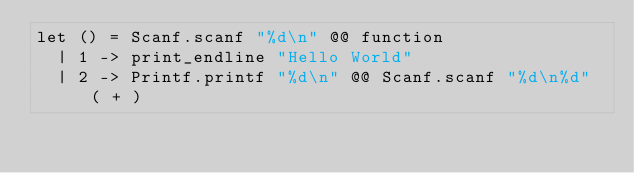<code> <loc_0><loc_0><loc_500><loc_500><_OCaml_>let () = Scanf.scanf "%d\n" @@ function
  | 1 -> print_endline "Hello World"
  | 2 -> Printf.printf "%d\n" @@ Scanf.scanf "%d\n%d" ( + )
</code> 